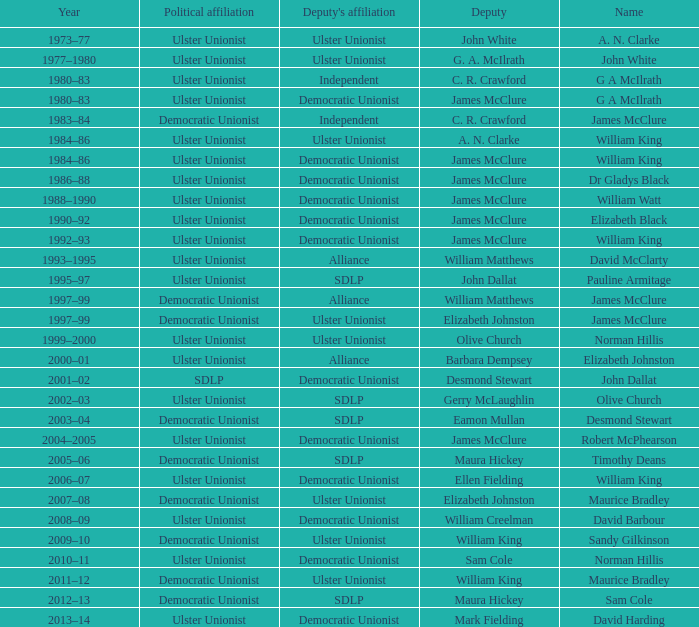What is the name of the deputy in 1992–93? James McClure. 